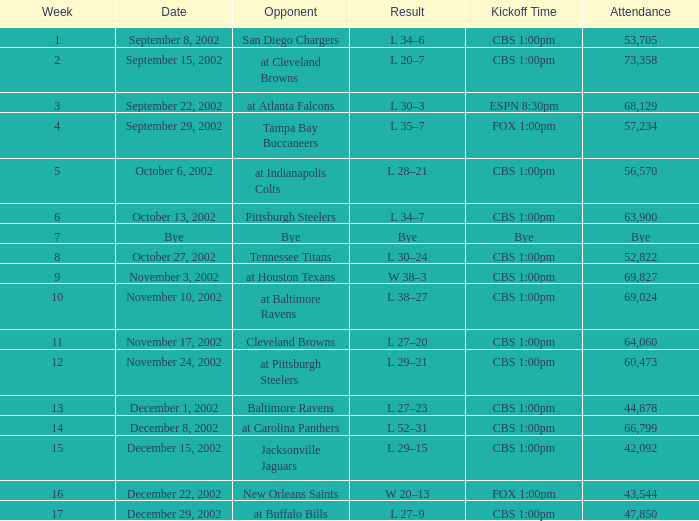In which week did the san diego chargers play as the opponent? 1.0. 